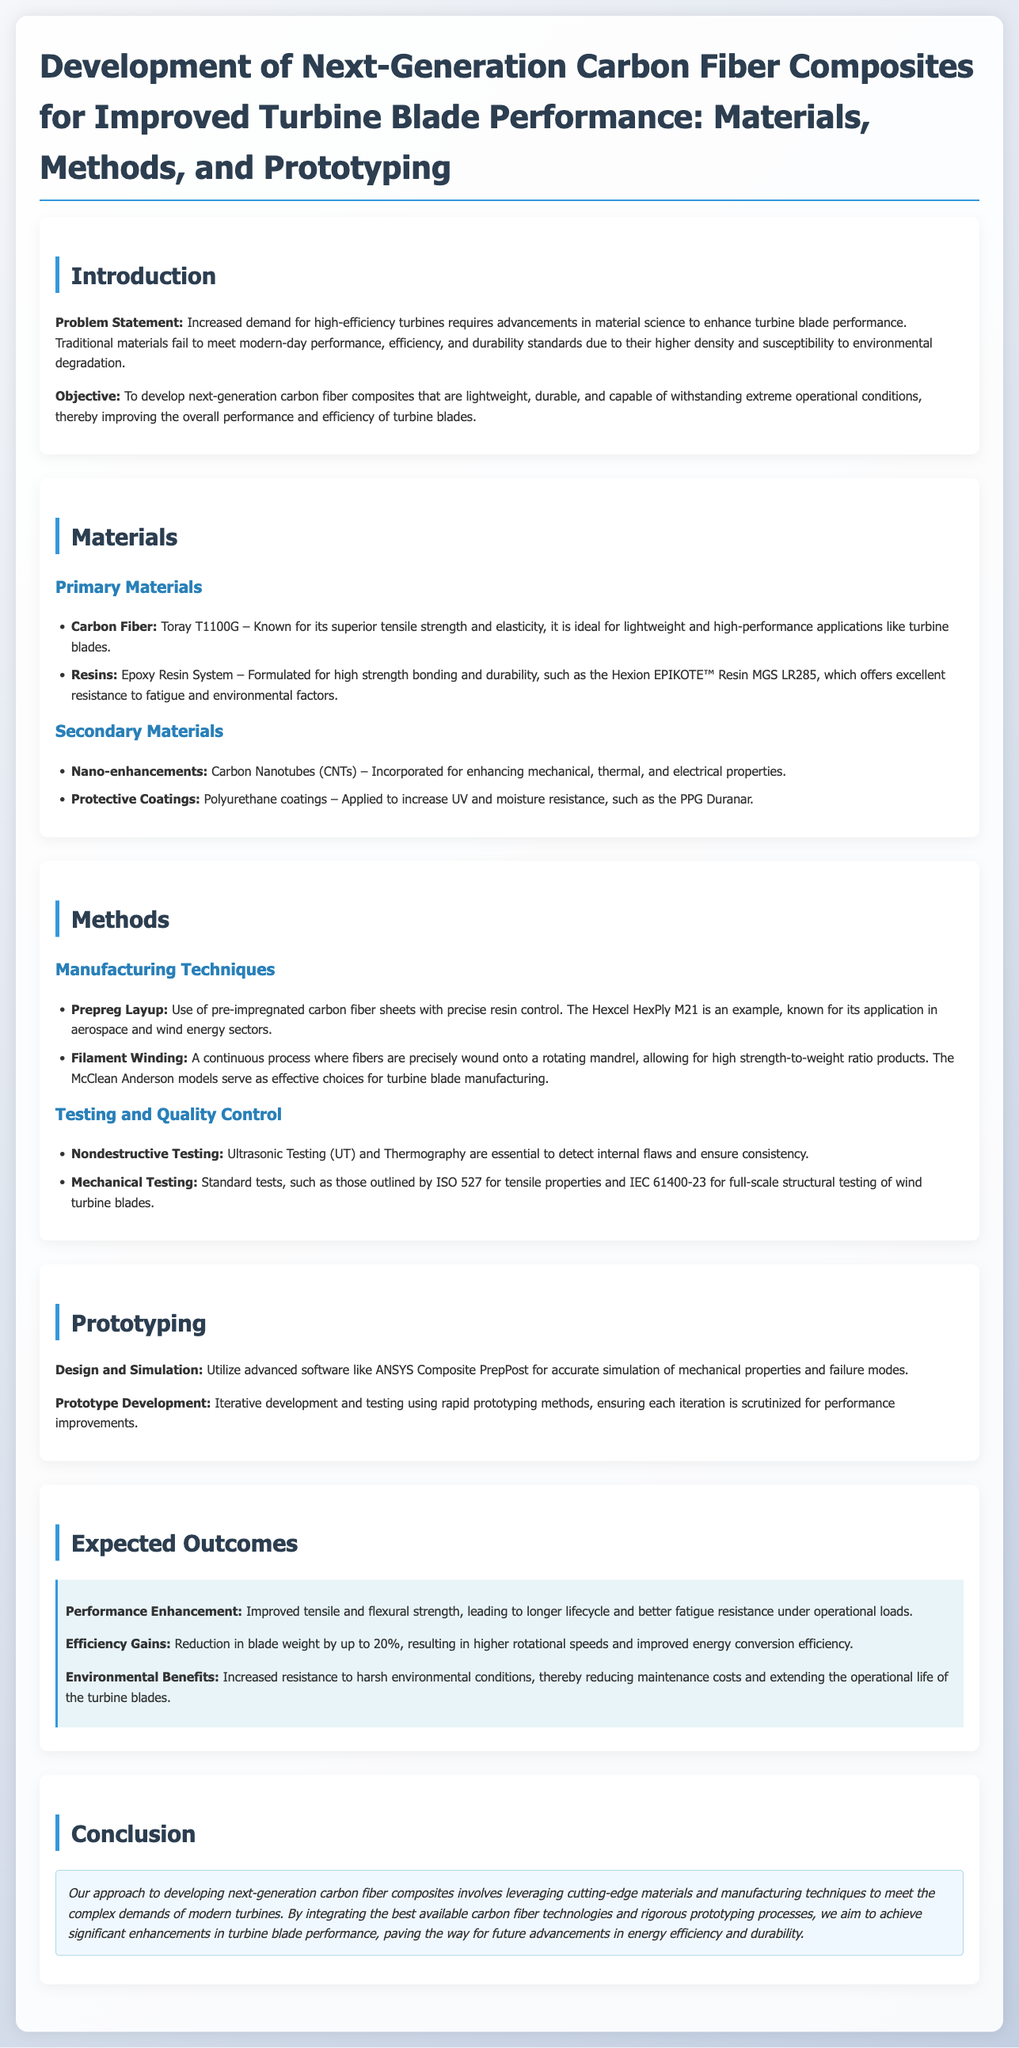What is the problem statement addressed in the proposal? The problem statement outlines the need for advancements in material science to enhance turbine blade performance due to traditional materials failing to meet modern-day standards.
Answer: Increased demand for high-efficiency turbines requires advancements in material science to enhance turbine blade performance What is the primary carbon fiber material mentioned? The primary carbon fiber material is specifically highlighted in the materials section of the document.
Answer: Toray T1100G Which resin is specifically formulated for high strength bonding? This resin is listed under the primary materials in the proposal, focusing on its suitability for turbine blades.
Answer: Hexion EPIKOTE™ Resin MGS LR285 What manufacturing technique involves the use of pre-impregnated carbon fiber sheets? The proposal discusses specific manufacturing methods related to carbon fiber composites for turbine blades, identifying this particular technique.
Answer: Prepreg Layup What is the expected reduction in blade weight? The expected outcomes section provides a specific numerical value regarding weight reduction, which contributes to efficiency gains.
Answer: Up to 20% Which software is utilized for the design and simulation of mechanical properties? This software is mentioned in the prototyping section of the proposal as a key tool for simulation and testing.
Answer: ANSYS Composite PrepPost What type of testing is essential for detecting internal flaws? The proposal describes testing methods, highlighting one that is crucial for ensuring the integrity of the materials used.
Answer: Ultrasonic Testing (UT) What is the objective of the proposal? The objective states the intentions behind the development of advanced carbon fiber composites to improve performance and efficiency.
Answer: To develop next-generation carbon fiber composites that are lightweight, durable, and capable of withstanding extreme operational conditions 